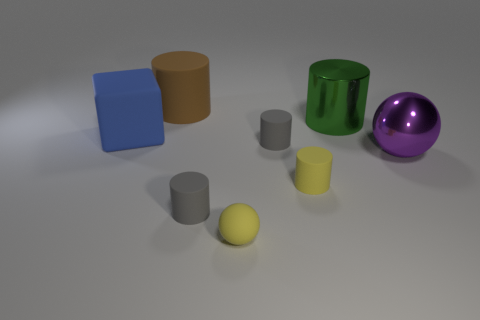What time of day does the lighting in the scene suggest? The soft shadows and muted light quality suggest an indoor setting with artificial lighting rather than natural daylight. 